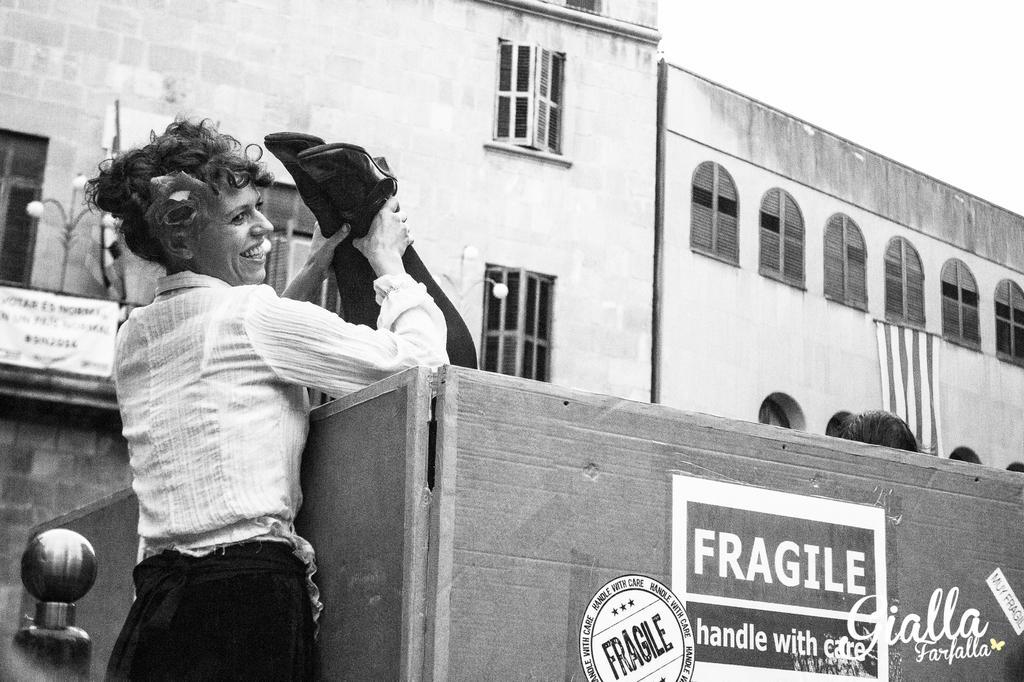Can you describe this image briefly? This is black and white image, in this image a woman holding legs in a box, in the background there are buildings. 